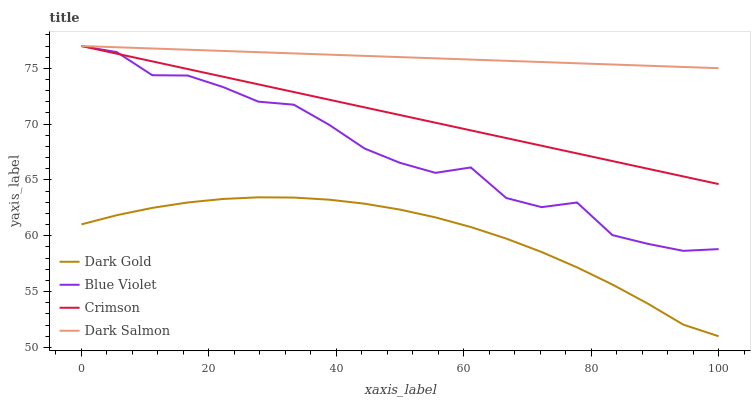Does Dark Gold have the minimum area under the curve?
Answer yes or no. Yes. Does Dark Salmon have the maximum area under the curve?
Answer yes or no. Yes. Does Blue Violet have the minimum area under the curve?
Answer yes or no. No. Does Blue Violet have the maximum area under the curve?
Answer yes or no. No. Is Dark Salmon the smoothest?
Answer yes or no. Yes. Is Blue Violet the roughest?
Answer yes or no. Yes. Is Blue Violet the smoothest?
Answer yes or no. No. Is Dark Salmon the roughest?
Answer yes or no. No. Does Dark Gold have the lowest value?
Answer yes or no. Yes. Does Blue Violet have the lowest value?
Answer yes or no. No. Does Blue Violet have the highest value?
Answer yes or no. Yes. Does Dark Gold have the highest value?
Answer yes or no. No. Is Dark Gold less than Dark Salmon?
Answer yes or no. Yes. Is Crimson greater than Dark Gold?
Answer yes or no. Yes. Does Crimson intersect Dark Salmon?
Answer yes or no. Yes. Is Crimson less than Dark Salmon?
Answer yes or no. No. Is Crimson greater than Dark Salmon?
Answer yes or no. No. Does Dark Gold intersect Dark Salmon?
Answer yes or no. No. 